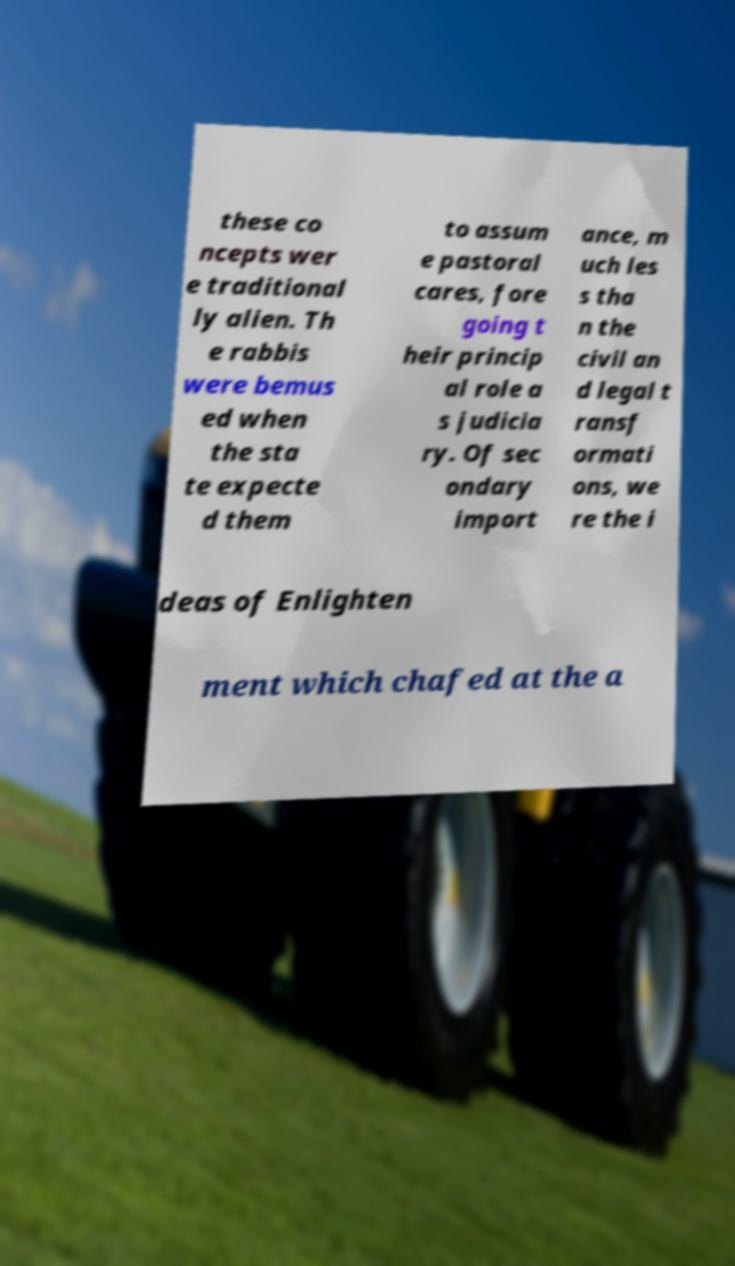Could you extract and type out the text from this image? these co ncepts wer e traditional ly alien. Th e rabbis were bemus ed when the sta te expecte d them to assum e pastoral cares, fore going t heir princip al role a s judicia ry. Of sec ondary import ance, m uch les s tha n the civil an d legal t ransf ormati ons, we re the i deas of Enlighten ment which chafed at the a 